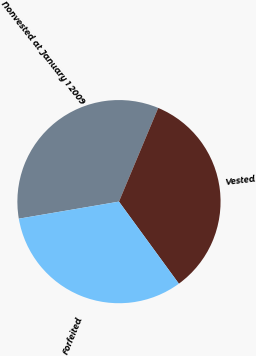Convert chart. <chart><loc_0><loc_0><loc_500><loc_500><pie_chart><fcel>Nonvested at January 1 2009<fcel>Vested<fcel>Forfeited<nl><fcel>34.0%<fcel>33.65%<fcel>32.35%<nl></chart> 